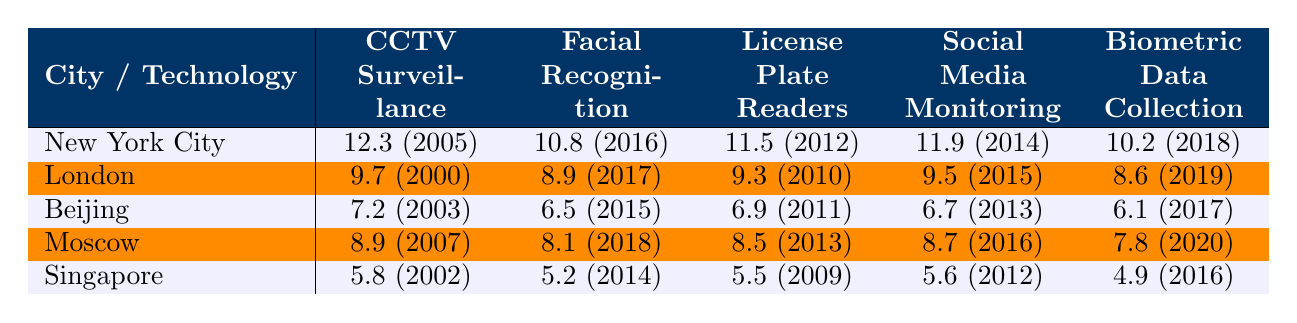What is the crime rate associated with Facial Recognition technology in London? According to the table, the crime rate for Facial Recognition technology in London is listed as 8.9.
Answer: 8.9 What was the implementation year for CCTV Surveillance in Singapore? The table indicates that Singapore implemented CCTV Surveillance in 2002.
Answer: 2002 Which city has the highest crime rate for Social Media Monitoring? By visual inspection, New York City has the highest crime rate for Social Media Monitoring at 11.9.
Answer: New York City What is the average crime rate across all technologies in Beijing? To find the average, we add the crime rates for all technologies in Beijing: (7.2 + 6.5 + 6.9 + 6.7 + 6.1) = 33.4. Then, divide by the number of technologies (5): 33.4 / 5 = 6.68.
Answer: 6.68 Is it true that Singapore has the lowest crime rate for Biometric Data Collection among the listed cities? By examining the table, Singapore's crime rate for Biometric Data Collection is 4.9, which is lower than all other cities listed, confirming that the statement is true.
Answer: Yes How does the average crime rate for CCTV Surveillance compare to that of Facial Recognition across all cities? The average for CCTV Surveillance is calculated as follows: (12.3 + 9.7 + 7.2 + 8.9 + 5.8) = 43.9, divided by 5 gives 8.78. The average for Facial Recognition is (10.8 + 8.9 + 6.5 + 8.1 + 5.2) = 39.5, divided by 5 gives 7.9. Comparing the two, 8.78 is higher than 7.9.
Answer: CCTV Surveillance is higher What city implemented License Plate Readers the earliest? The data shows the implementation years: New York City in 2012, London in 2010, Beijing in 2011, Moscow in 2013, and Singapore in 2009. Singapore has the earliest year at 2009.
Answer: Singapore Which technology has the highest crime rate in Moscow? Looking at the table for Moscow, the highest crime rate is associated with CCTV Surveillance, which is 8.9.
Answer: CCTV Surveillance Calculate the difference in crime rates for Biometric Data Collection between New York City and Beijing. The crime rate for Biometric Data Collection in New York City is 10.2 and in Beijing it is 6.1. The difference is 10.2 - 6.1 = 4.1.
Answer: 4.1 Which city has the smallest crime rate for Facial Recognition, and what is that rate? By checking the table, Beijing has the smallest crime rate for Facial Recognition at 6.5.
Answer: Beijing, 6.5 What is the total crime rate for all technologies in London? Calculating the total for London: (9.7 + 8.9 + 9.3 + 9.5 + 8.6) = 46.0.
Answer: 46.0 